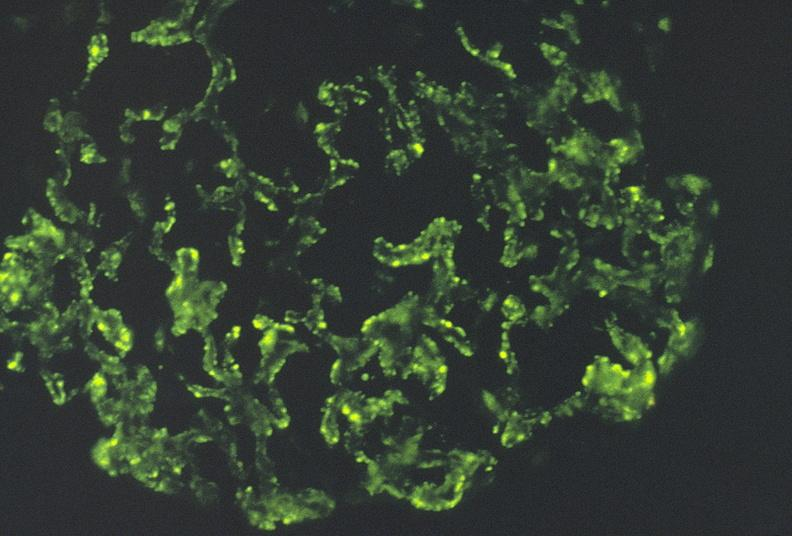where is this?
Answer the question using a single word or phrase. Urinary 